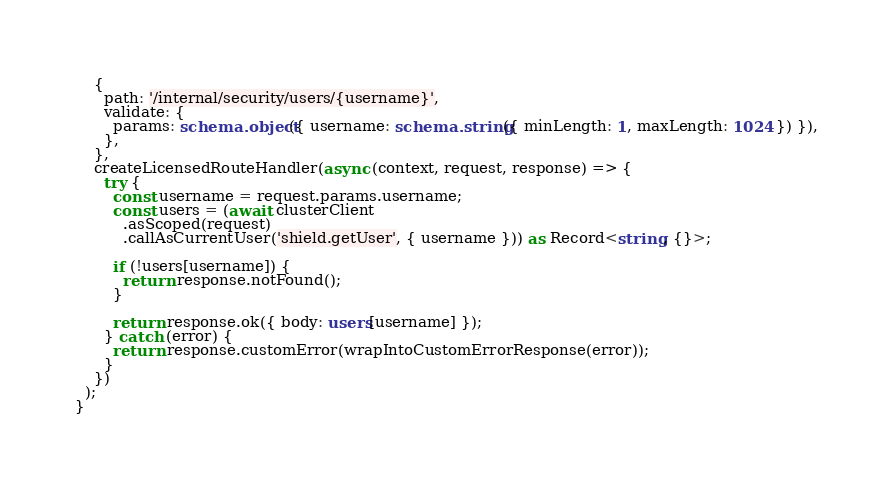<code> <loc_0><loc_0><loc_500><loc_500><_TypeScript_>    {
      path: '/internal/security/users/{username}',
      validate: {
        params: schema.object({ username: schema.string({ minLength: 1, maxLength: 1024 }) }),
      },
    },
    createLicensedRouteHandler(async (context, request, response) => {
      try {
        const username = request.params.username;
        const users = (await clusterClient
          .asScoped(request)
          .callAsCurrentUser('shield.getUser', { username })) as Record<string, {}>;

        if (!users[username]) {
          return response.notFound();
        }

        return response.ok({ body: users[username] });
      } catch (error) {
        return response.customError(wrapIntoCustomErrorResponse(error));
      }
    })
  );
}
</code> 